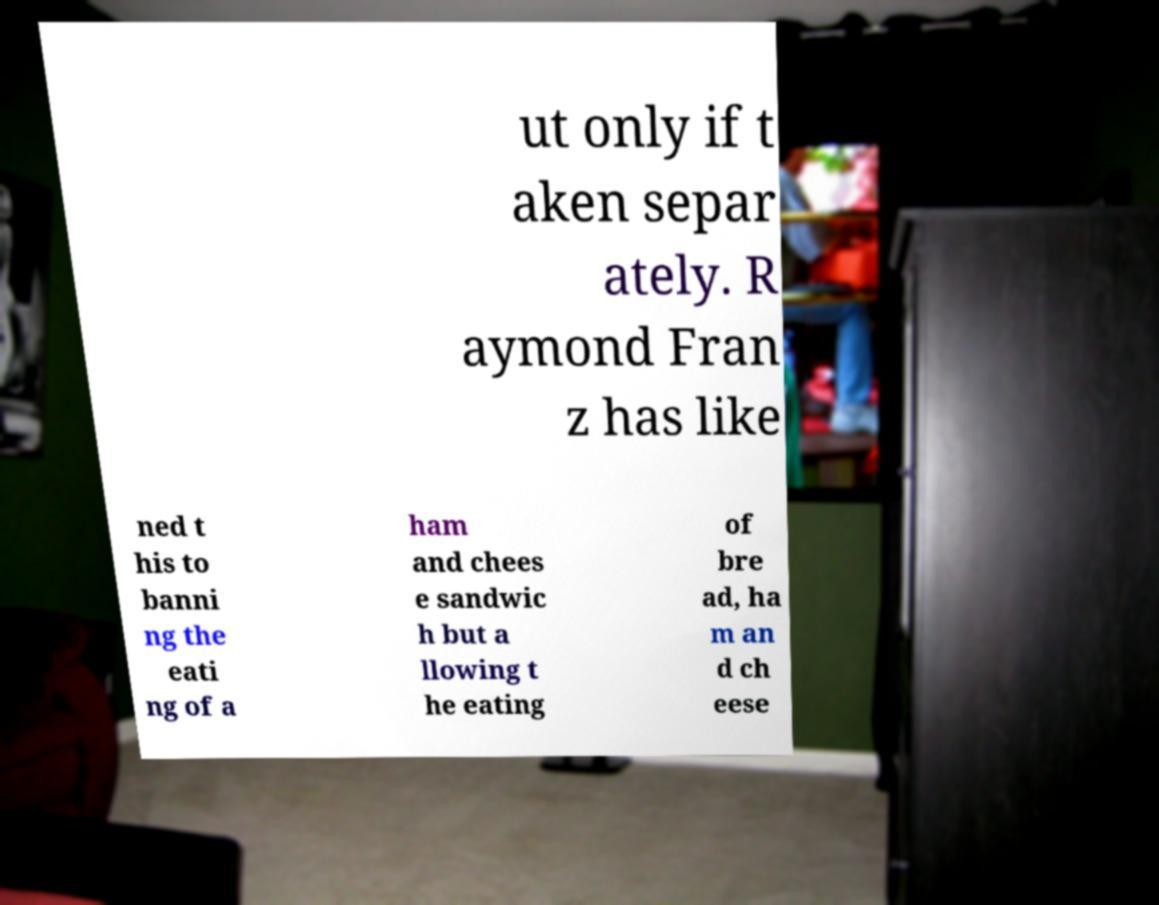I need the written content from this picture converted into text. Can you do that? ut only if t aken separ ately. R aymond Fran z has like ned t his to banni ng the eati ng of a ham and chees e sandwic h but a llowing t he eating of bre ad, ha m an d ch eese 